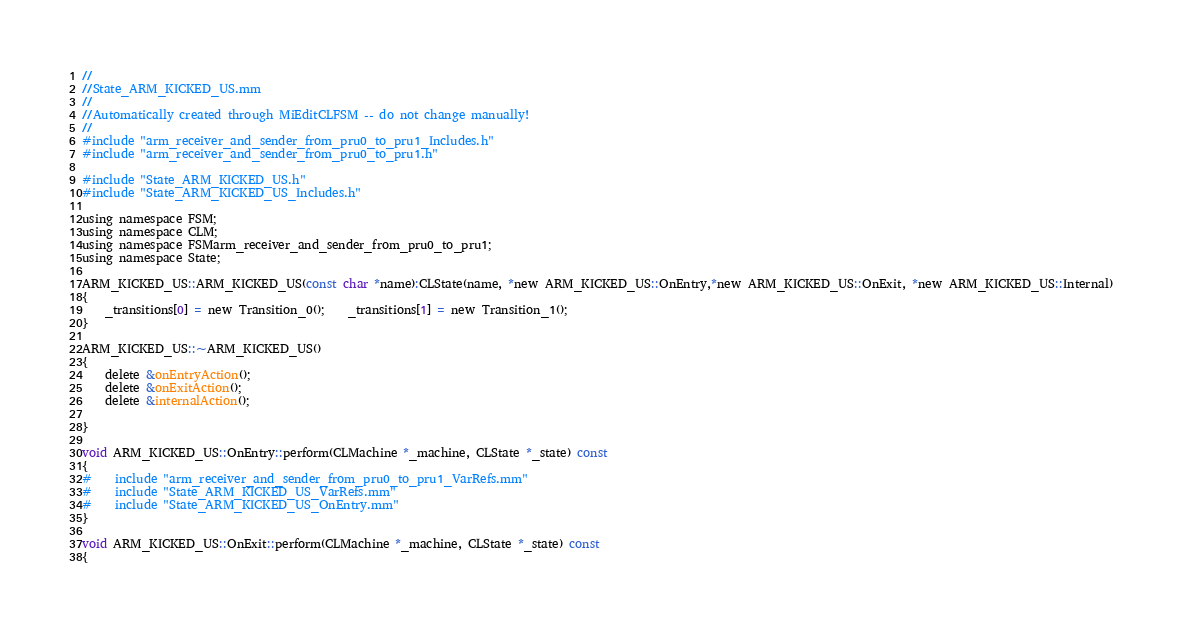<code> <loc_0><loc_0><loc_500><loc_500><_ObjectiveC_>//
//State_ARM_KICKED_US.mm
//
//Automatically created through MiEditCLFSM -- do not change manually!
//
#include "arm_receiver_and_sender_from_pru0_to_pru1_Includes.h"
#include "arm_receiver_and_sender_from_pru0_to_pru1.h"

#include "State_ARM_KICKED_US.h"
#include "State_ARM_KICKED_US_Includes.h"

using namespace FSM;
using namespace CLM;
using namespace FSMarm_receiver_and_sender_from_pru0_to_pru1;
using namespace State;

ARM_KICKED_US::ARM_KICKED_US(const char *name):CLState(name, *new ARM_KICKED_US::OnEntry,*new ARM_KICKED_US::OnExit, *new ARM_KICKED_US::Internal)
{
	_transitions[0] = new Transition_0();	_transitions[1] = new Transition_1();
}

ARM_KICKED_US::~ARM_KICKED_US()
{
	delete &onEntryAction();
	delete &onExitAction();
	delete &internalAction();

}

void ARM_KICKED_US::OnEntry::perform(CLMachine *_machine, CLState *_state) const
{
#	include "arm_receiver_and_sender_from_pru0_to_pru1_VarRefs.mm"
#	include "State_ARM_KICKED_US_VarRefs.mm"
#	include "State_ARM_KICKED_US_OnEntry.mm"
}

void ARM_KICKED_US::OnExit::perform(CLMachine *_machine, CLState *_state) const
{</code> 